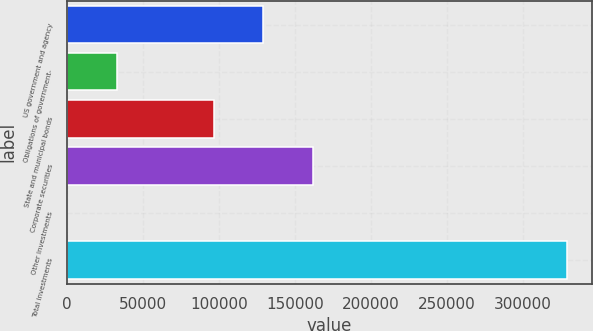Convert chart. <chart><loc_0><loc_0><loc_500><loc_500><bar_chart><fcel>US government and agency<fcel>Obligations of government-<fcel>State and municipal bonds<fcel>Corporate securities<fcel>Other investments<fcel>Total investments<nl><fcel>129259<fcel>32912<fcel>96383<fcel>162135<fcel>36<fcel>328796<nl></chart> 